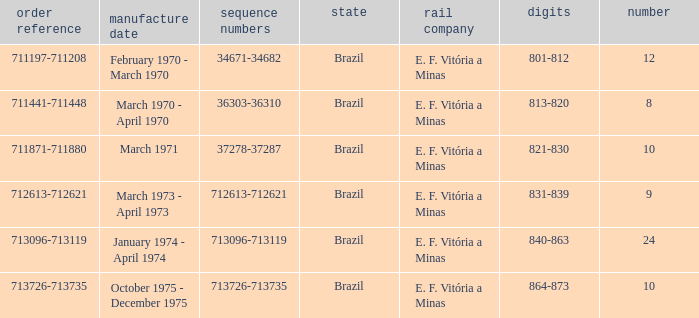The numbers 801-812 are in which country? Brazil. 